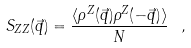<formula> <loc_0><loc_0><loc_500><loc_500>S _ { Z Z } ( \vec { q } ) = \frac { \langle \rho ^ { Z } ( \vec { q } ) \rho ^ { Z } ( - \vec { q } ) \rangle } { N } \ ,</formula> 